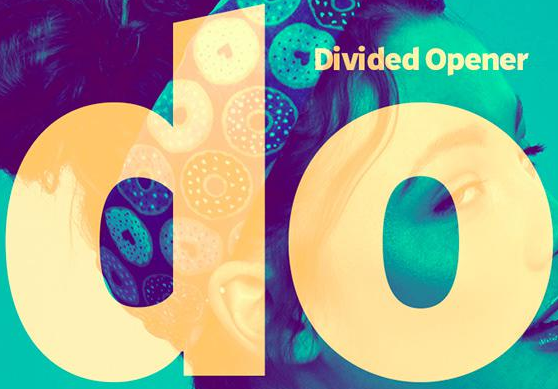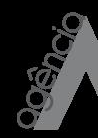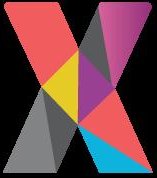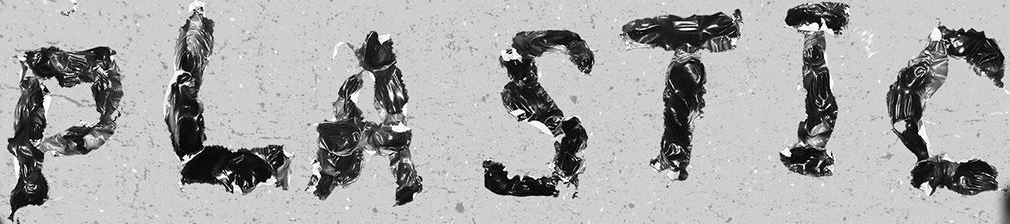Read the text content from these images in order, separated by a semicolon. do; agência; X; PLASTIC 